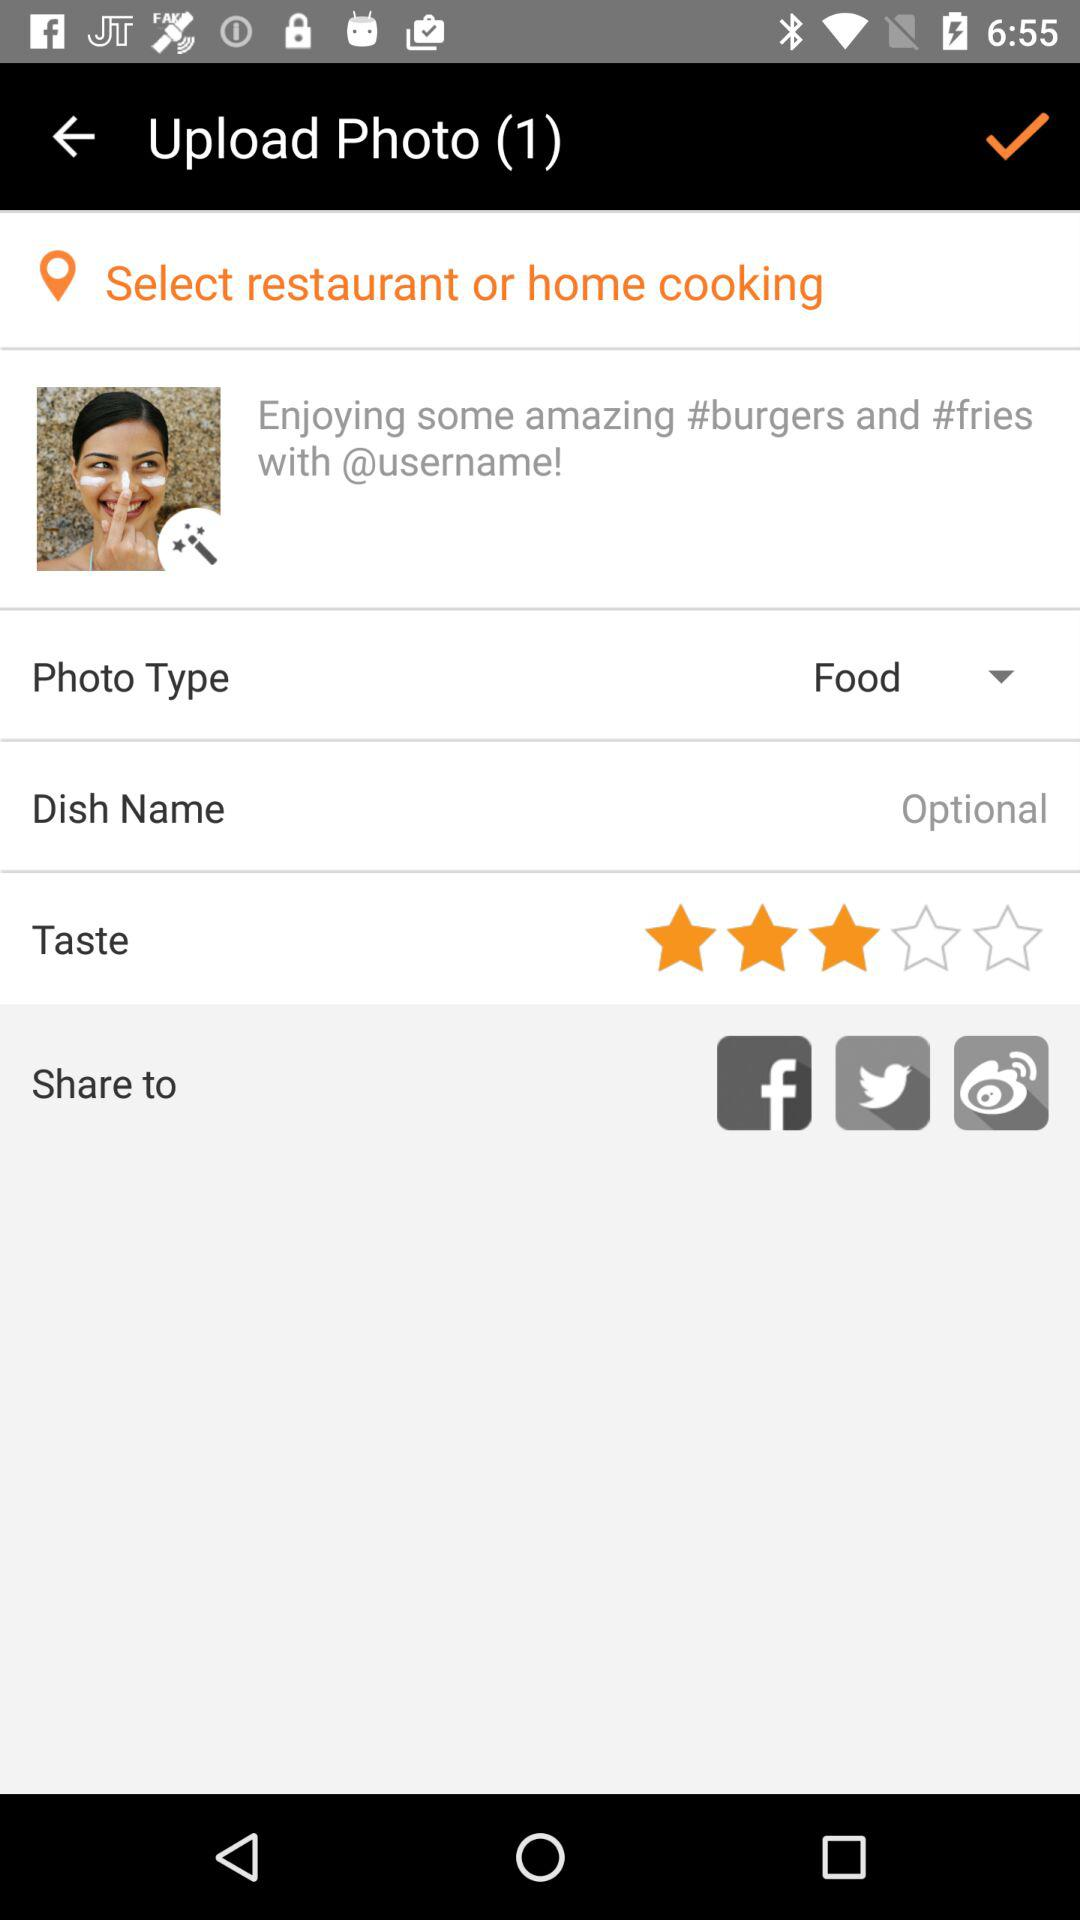What are the sharing options? The sharing options are "Facebook", "Twitter" and "Weibo". 